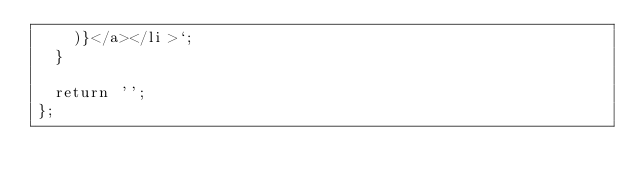<code> <loc_0><loc_0><loc_500><loc_500><_TypeScript_>    )}</a></li>`;
  }

  return '';
};
</code> 